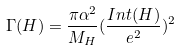Convert formula to latex. <formula><loc_0><loc_0><loc_500><loc_500>\Gamma ( H ) = \frac { \pi \alpha ^ { 2 } } { M _ { H } } ( \frac { I n t ( H ) } { e ^ { 2 } } ) ^ { 2 }</formula> 